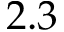<formula> <loc_0><loc_0><loc_500><loc_500>2 . 3</formula> 